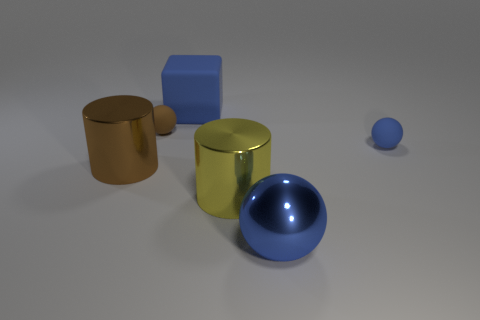Subtract all blue spheres. How many spheres are left? 1 Add 1 blue matte balls. How many objects exist? 7 Subtract 1 cylinders. How many cylinders are left? 1 Subtract all brown spheres. How many spheres are left? 2 Subtract all cubes. How many objects are left? 5 Subtract all cyan blocks. How many brown balls are left? 1 Subtract all big blue metal balls. Subtract all blue things. How many objects are left? 2 Add 2 small brown rubber spheres. How many small brown rubber spheres are left? 3 Add 2 cyan rubber objects. How many cyan rubber objects exist? 2 Subtract 0 brown cubes. How many objects are left? 6 